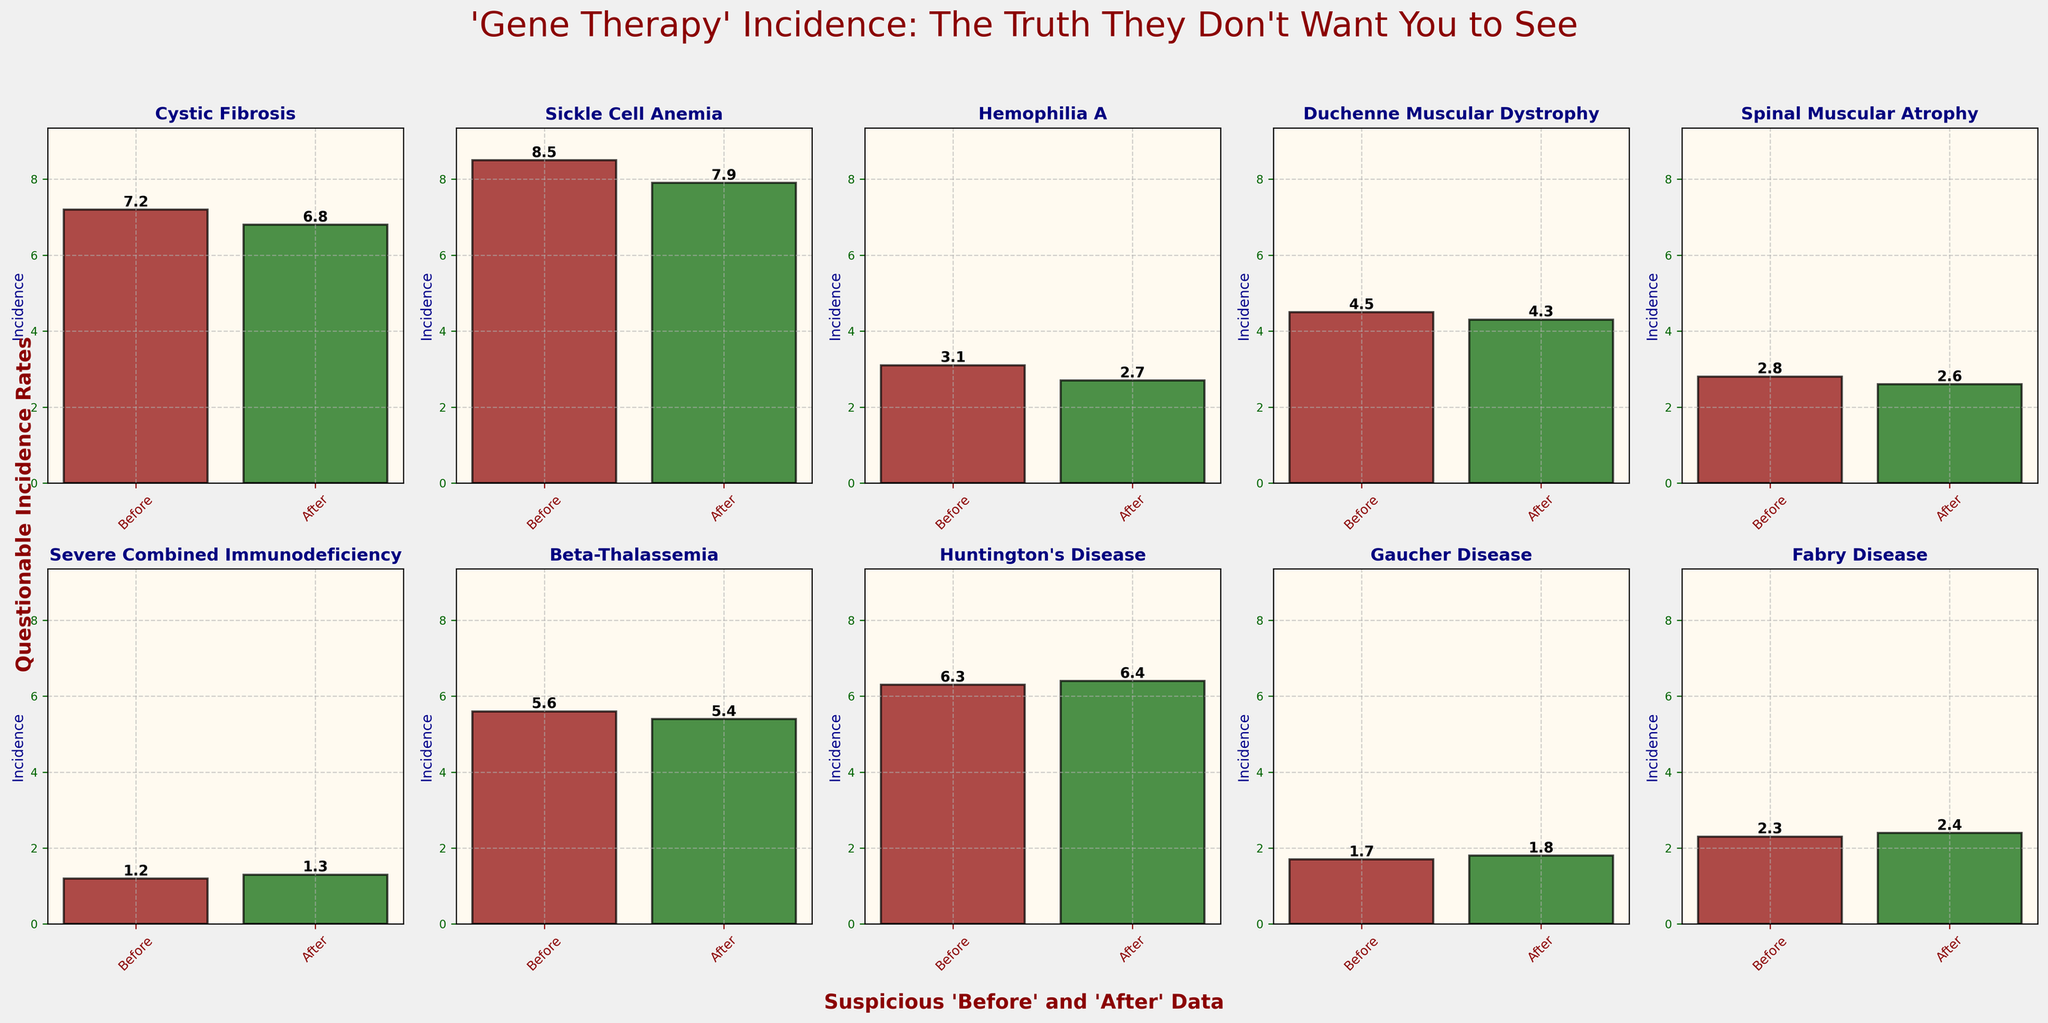What's the title of the figure? The title of the figure is displayed prominently at the top of the plot area. It reads "'Gene Therapy' Incidence: The Truth They Don't Want You to See".
Answer: 'Gene Therapy' Incidence: The Truth They Don't Want You to See What's the incidence rate of Cystic Fibrosis before gene therapy? Look at the subplot for Cystic Fibrosis and read the value on the 'Before' bar. It is labeled as 7.2.
Answer: 7.2 Which disease shows an increase in incidence after gene therapy? Compare the 'Before' and 'After' bars for each disease. Huntington's Disease, Gaucher Disease, and Fabry Disease all show an increase, but we'll list just one for the concise answer.
Answer: Huntington's Disease What's the difference in incidence of Sickle Cell Anemia before and after gene therapy? Subtract the value of 'After' gene therapy bar for Sickle Cell Anemia from the value of 'Before' gene therapy bar. The values are 8.5 and 7.9 respectively. So, 8.5 - 7.9 = 0.6.
Answer: 0.6 Which disease has the lowest incidence after gene therapy trials? Look at the 'After' bars in each subplot and find the smallest value. Severe Combined Immunodeficiency has the lowest value of 1.3.
Answer: Severe Combined Immunodeficiency What's the average incidence rate of all diseases after gene therapy? Sum the 'After' values for all diseases and divide by the number of diseases. (6.8 + 7.9 + 2.7 + 4.3 + 2.6 + 1.3 + 5.4 + 6.4 + 1.8 + 2.4) = 41.6, then 41.6 / 10 = 4.16.
Answer: 4.16 Compare the incidence change in Hemophilia A and Duchenne Muscular Dystrophy. Which one shows a larger decrease? Calculate the difference for both diseases by subtracting 'After' from 'Before'. Hemophilia A: 3.1 - 2.7 = 0.4 and Duchenne Muscular Dystrophy: 4.5 - 4.3 = 0.2. Hemophilia A shows a larger decrease.
Answer: Hemophilia A What is the total incidence rate for Beta-Thalassemia before and after gene therapy? Add the 'Before' and 'After' values for Beta-Thalassemia. The values are 5.6 and 5.4 respectively. So, 5.6 + 5.4 = 11.0.
Answer: 11.0 How many diseases show a reduction in incidence after gene therapy? Count the number of diseases where 'After' bar is lower than the 'Before' bar. There are six diseases: Cystic Fibrosis, Sickle Cell Anemia, Hemophilia A, Duchenne Muscular Dystrophy, Spinal Muscular Atrophy, and Beta-Thalassemia.
Answer: 6 In which subplot is the 'After' incidence rate higher than the 'Before'? Examine each subplot and identify the ones where the 'After' bar is taller than the 'Before' bar. The diseases are Severe Combined Immunodeficiency, Huntington's Disease, Gaucher Disease, and Fabry Disease.
Answer: Severe Combined Immunodeficiency, Huntington's Disease, Gaucher Disease, Fabry Disease 